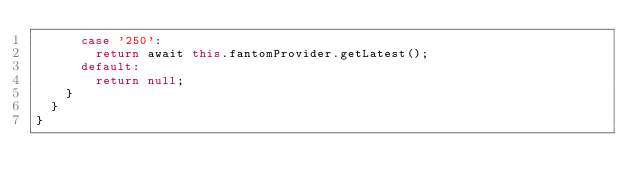Convert code to text. <code><loc_0><loc_0><loc_500><loc_500><_TypeScript_>      case '250':
        return await this.fantomProvider.getLatest();
      default:
        return null;
    }
  }
}
</code> 